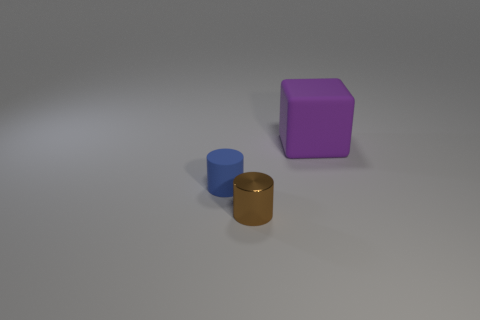Considering the shadows in the image, where might the light source be located? The shadows cast by the objects suggest the light source is positioned to the upper left of the scene, out of the frame. The shadows are soft-edged, indicating the light source is not too close to the objects. 